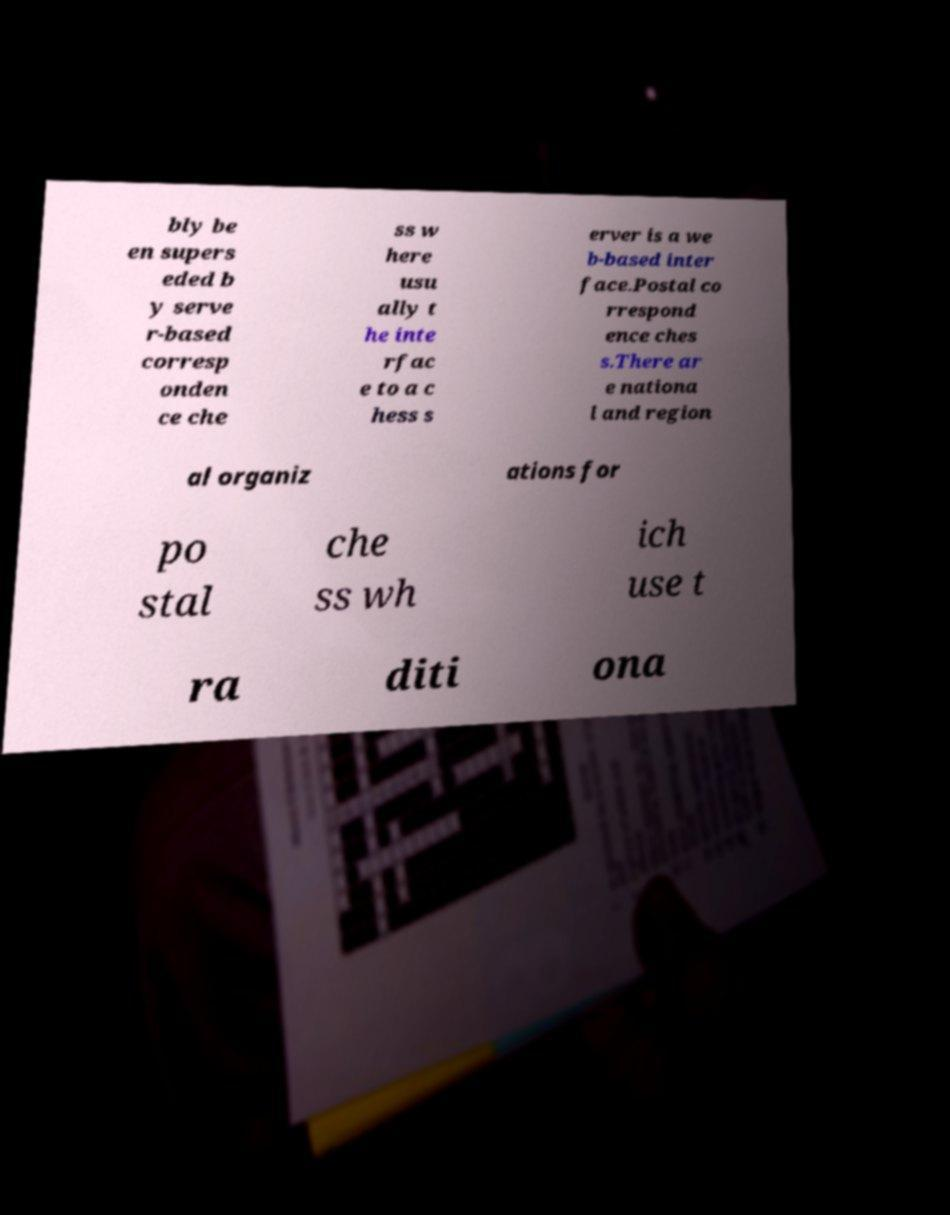Could you assist in decoding the text presented in this image and type it out clearly? bly be en supers eded b y serve r-based corresp onden ce che ss w here usu ally t he inte rfac e to a c hess s erver is a we b-based inter face.Postal co rrespond ence ches s.There ar e nationa l and region al organiz ations for po stal che ss wh ich use t ra diti ona 